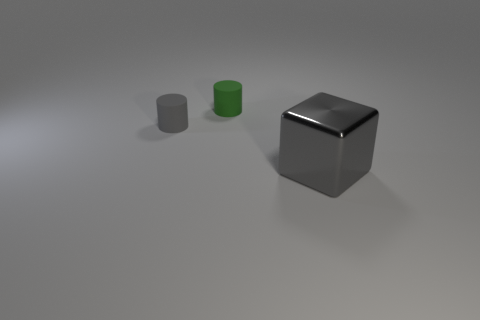Add 1 cylinders. How many objects exist? 4 Subtract all blocks. How many objects are left? 2 Add 1 big red cylinders. How many big red cylinders exist? 1 Subtract 0 cyan spheres. How many objects are left? 3 Subtract all small shiny blocks. Subtract all tiny gray rubber cylinders. How many objects are left? 2 Add 3 gray objects. How many gray objects are left? 5 